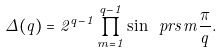Convert formula to latex. <formula><loc_0><loc_0><loc_500><loc_500>\Delta ( q ) = 2 ^ { q - 1 } \prod _ { m = 1 } ^ { q - 1 } \sin \ p r s { m \frac { \pi } q } .</formula> 